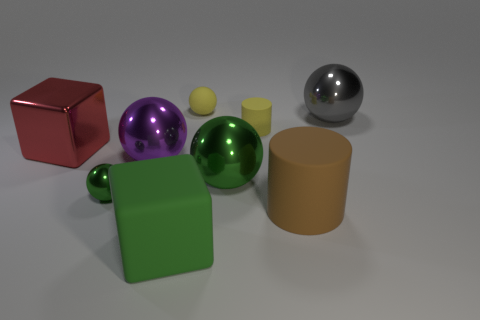Subtract all rubber balls. How many balls are left? 4 Subtract all purple balls. How many balls are left? 4 Subtract all red balls. Subtract all gray blocks. How many balls are left? 5 Subtract all blocks. How many objects are left? 7 Add 9 large purple metallic spheres. How many large purple metallic spheres are left? 10 Add 4 green matte balls. How many green matte balls exist? 4 Subtract 2 green balls. How many objects are left? 7 Subtract all large green things. Subtract all purple spheres. How many objects are left? 6 